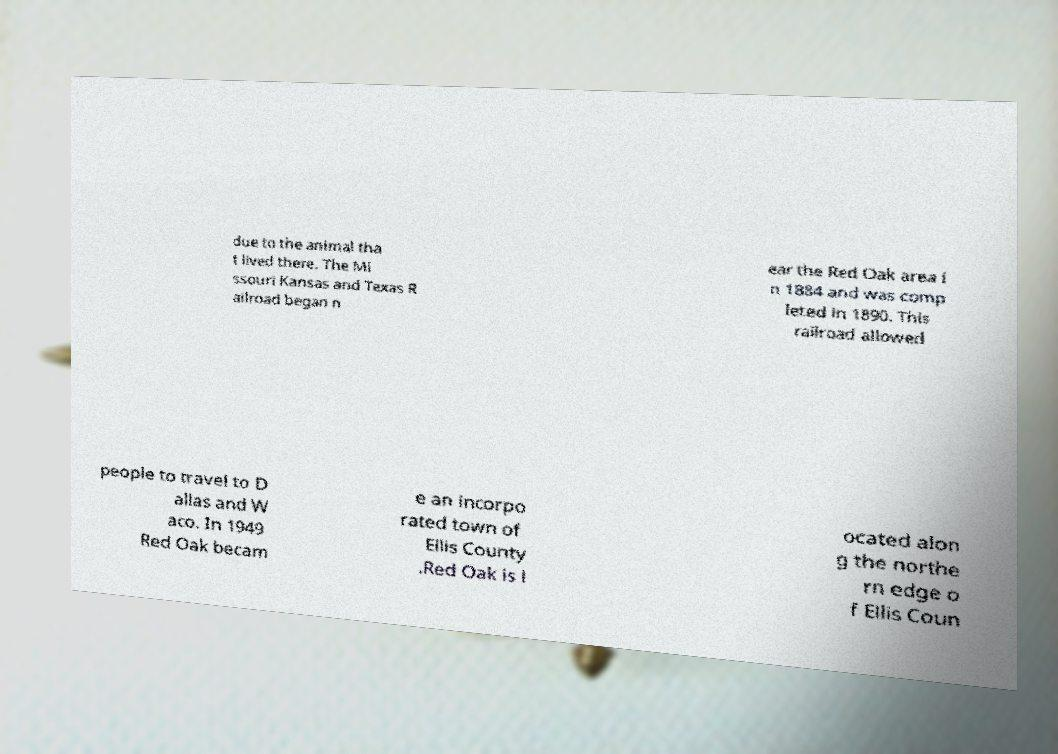For documentation purposes, I need the text within this image transcribed. Could you provide that? due to the animal tha t lived there. The Mi ssouri Kansas and Texas R ailroad began n ear the Red Oak area i n 1884 and was comp leted in 1890. This railroad allowed people to travel to D allas and W aco. In 1949 Red Oak becam e an incorpo rated town of Ellis County .Red Oak is l ocated alon g the northe rn edge o f Ellis Coun 